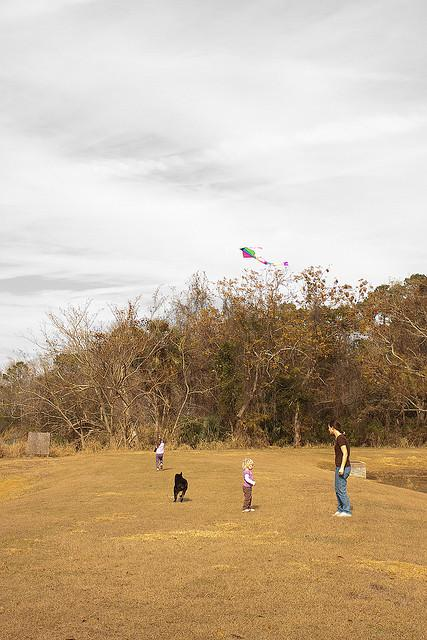What breed dog it is? doberman 